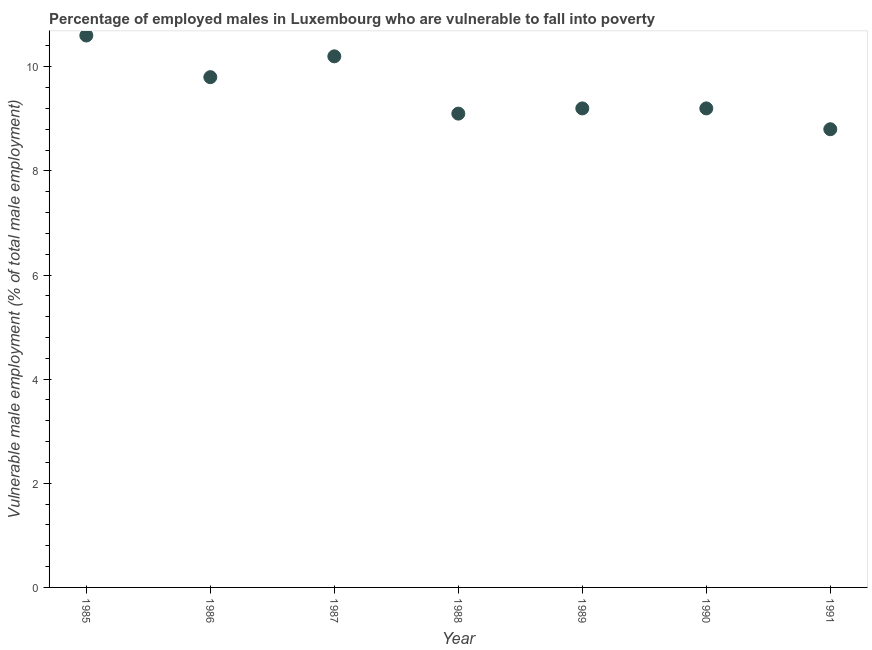What is the percentage of employed males who are vulnerable to fall into poverty in 1985?
Your answer should be very brief. 10.6. Across all years, what is the maximum percentage of employed males who are vulnerable to fall into poverty?
Give a very brief answer. 10.6. Across all years, what is the minimum percentage of employed males who are vulnerable to fall into poverty?
Offer a terse response. 8.8. What is the sum of the percentage of employed males who are vulnerable to fall into poverty?
Give a very brief answer. 66.9. What is the difference between the percentage of employed males who are vulnerable to fall into poverty in 1985 and 1990?
Ensure brevity in your answer.  1.4. What is the average percentage of employed males who are vulnerable to fall into poverty per year?
Give a very brief answer. 9.56. What is the median percentage of employed males who are vulnerable to fall into poverty?
Make the answer very short. 9.2. In how many years, is the percentage of employed males who are vulnerable to fall into poverty greater than 1.6 %?
Give a very brief answer. 7. Do a majority of the years between 1990 and 1985 (inclusive) have percentage of employed males who are vulnerable to fall into poverty greater than 10 %?
Your answer should be compact. Yes. What is the ratio of the percentage of employed males who are vulnerable to fall into poverty in 1987 to that in 1989?
Offer a terse response. 1.11. Is the difference between the percentage of employed males who are vulnerable to fall into poverty in 1986 and 1987 greater than the difference between any two years?
Your response must be concise. No. What is the difference between the highest and the second highest percentage of employed males who are vulnerable to fall into poverty?
Give a very brief answer. 0.4. Is the sum of the percentage of employed males who are vulnerable to fall into poverty in 1987 and 1991 greater than the maximum percentage of employed males who are vulnerable to fall into poverty across all years?
Keep it short and to the point. Yes. What is the difference between the highest and the lowest percentage of employed males who are vulnerable to fall into poverty?
Provide a short and direct response. 1.8. How many years are there in the graph?
Your response must be concise. 7. What is the difference between two consecutive major ticks on the Y-axis?
Provide a short and direct response. 2. Are the values on the major ticks of Y-axis written in scientific E-notation?
Ensure brevity in your answer.  No. Does the graph contain grids?
Give a very brief answer. No. What is the title of the graph?
Offer a terse response. Percentage of employed males in Luxembourg who are vulnerable to fall into poverty. What is the label or title of the Y-axis?
Your answer should be very brief. Vulnerable male employment (% of total male employment). What is the Vulnerable male employment (% of total male employment) in 1985?
Offer a terse response. 10.6. What is the Vulnerable male employment (% of total male employment) in 1986?
Your answer should be very brief. 9.8. What is the Vulnerable male employment (% of total male employment) in 1987?
Offer a very short reply. 10.2. What is the Vulnerable male employment (% of total male employment) in 1988?
Offer a very short reply. 9.1. What is the Vulnerable male employment (% of total male employment) in 1989?
Give a very brief answer. 9.2. What is the Vulnerable male employment (% of total male employment) in 1990?
Give a very brief answer. 9.2. What is the Vulnerable male employment (% of total male employment) in 1991?
Keep it short and to the point. 8.8. What is the difference between the Vulnerable male employment (% of total male employment) in 1985 and 1986?
Offer a very short reply. 0.8. What is the difference between the Vulnerable male employment (% of total male employment) in 1985 and 1987?
Provide a succinct answer. 0.4. What is the difference between the Vulnerable male employment (% of total male employment) in 1985 and 1988?
Give a very brief answer. 1.5. What is the difference between the Vulnerable male employment (% of total male employment) in 1986 and 1988?
Keep it short and to the point. 0.7. What is the difference between the Vulnerable male employment (% of total male employment) in 1986 and 1990?
Offer a very short reply. 0.6. What is the difference between the Vulnerable male employment (% of total male employment) in 1986 and 1991?
Offer a terse response. 1. What is the difference between the Vulnerable male employment (% of total male employment) in 1987 and 1989?
Keep it short and to the point. 1. What is the difference between the Vulnerable male employment (% of total male employment) in 1987 and 1990?
Ensure brevity in your answer.  1. What is the difference between the Vulnerable male employment (% of total male employment) in 1988 and 1989?
Your answer should be compact. -0.1. What is the difference between the Vulnerable male employment (% of total male employment) in 1988 and 1991?
Your response must be concise. 0.3. What is the difference between the Vulnerable male employment (% of total male employment) in 1989 and 1991?
Keep it short and to the point. 0.4. What is the difference between the Vulnerable male employment (% of total male employment) in 1990 and 1991?
Provide a succinct answer. 0.4. What is the ratio of the Vulnerable male employment (% of total male employment) in 1985 to that in 1986?
Offer a terse response. 1.08. What is the ratio of the Vulnerable male employment (% of total male employment) in 1985 to that in 1987?
Offer a terse response. 1.04. What is the ratio of the Vulnerable male employment (% of total male employment) in 1985 to that in 1988?
Make the answer very short. 1.17. What is the ratio of the Vulnerable male employment (% of total male employment) in 1985 to that in 1989?
Ensure brevity in your answer.  1.15. What is the ratio of the Vulnerable male employment (% of total male employment) in 1985 to that in 1990?
Your answer should be very brief. 1.15. What is the ratio of the Vulnerable male employment (% of total male employment) in 1985 to that in 1991?
Offer a terse response. 1.21. What is the ratio of the Vulnerable male employment (% of total male employment) in 1986 to that in 1987?
Your response must be concise. 0.96. What is the ratio of the Vulnerable male employment (% of total male employment) in 1986 to that in 1988?
Make the answer very short. 1.08. What is the ratio of the Vulnerable male employment (% of total male employment) in 1986 to that in 1989?
Provide a short and direct response. 1.06. What is the ratio of the Vulnerable male employment (% of total male employment) in 1986 to that in 1990?
Your response must be concise. 1.06. What is the ratio of the Vulnerable male employment (% of total male employment) in 1986 to that in 1991?
Give a very brief answer. 1.11. What is the ratio of the Vulnerable male employment (% of total male employment) in 1987 to that in 1988?
Provide a short and direct response. 1.12. What is the ratio of the Vulnerable male employment (% of total male employment) in 1987 to that in 1989?
Ensure brevity in your answer.  1.11. What is the ratio of the Vulnerable male employment (% of total male employment) in 1987 to that in 1990?
Make the answer very short. 1.11. What is the ratio of the Vulnerable male employment (% of total male employment) in 1987 to that in 1991?
Make the answer very short. 1.16. What is the ratio of the Vulnerable male employment (% of total male employment) in 1988 to that in 1989?
Offer a very short reply. 0.99. What is the ratio of the Vulnerable male employment (% of total male employment) in 1988 to that in 1991?
Your answer should be very brief. 1.03. What is the ratio of the Vulnerable male employment (% of total male employment) in 1989 to that in 1991?
Your answer should be very brief. 1.04. What is the ratio of the Vulnerable male employment (% of total male employment) in 1990 to that in 1991?
Keep it short and to the point. 1.04. 